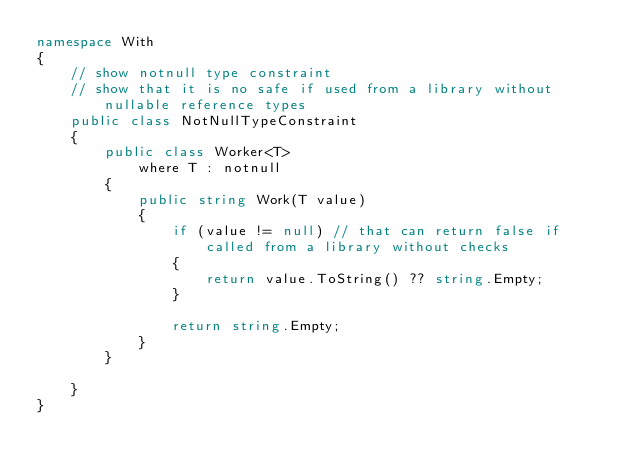<code> <loc_0><loc_0><loc_500><loc_500><_C#_>namespace With
{
    // show notnull type constraint
    // show that it is no safe if used from a library without nullable reference types
    public class NotNullTypeConstraint
    {
        public class Worker<T>
            where T : notnull
        {
            public string Work(T value)
            {
                if (value != null) // that can return false if called from a library without checks
                {
                    return value.ToString() ?? string.Empty;
                }

                return string.Empty;
            }
        }

    }
}</code> 